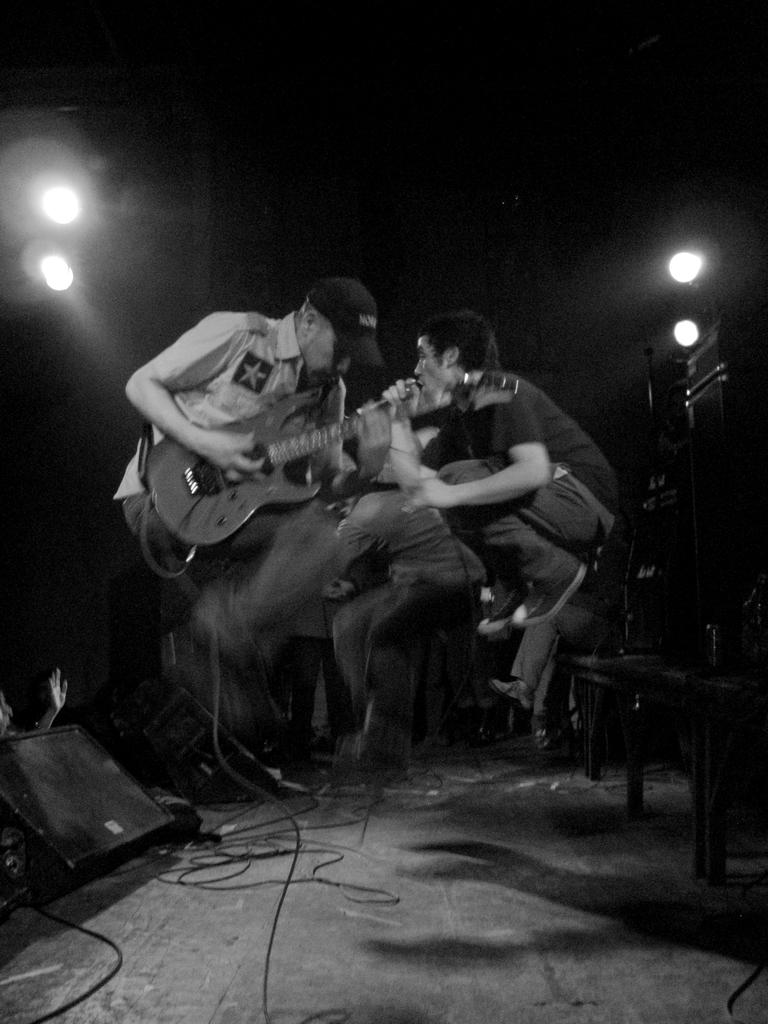What are the people in the center of the image doing? The people in the center of the image are sitting and holding musical instruments. What might the people be doing with the musical instruments? The people might be playing the musical instruments. What can be seen in the background of the image? There are lights visible in the background of the image. What type of lettuce is being used as a prop in the image? There is no lettuce present in the image. What flavor of mint can be tasted in the air during the performance? There is no mention of mint or any scent in the image. 